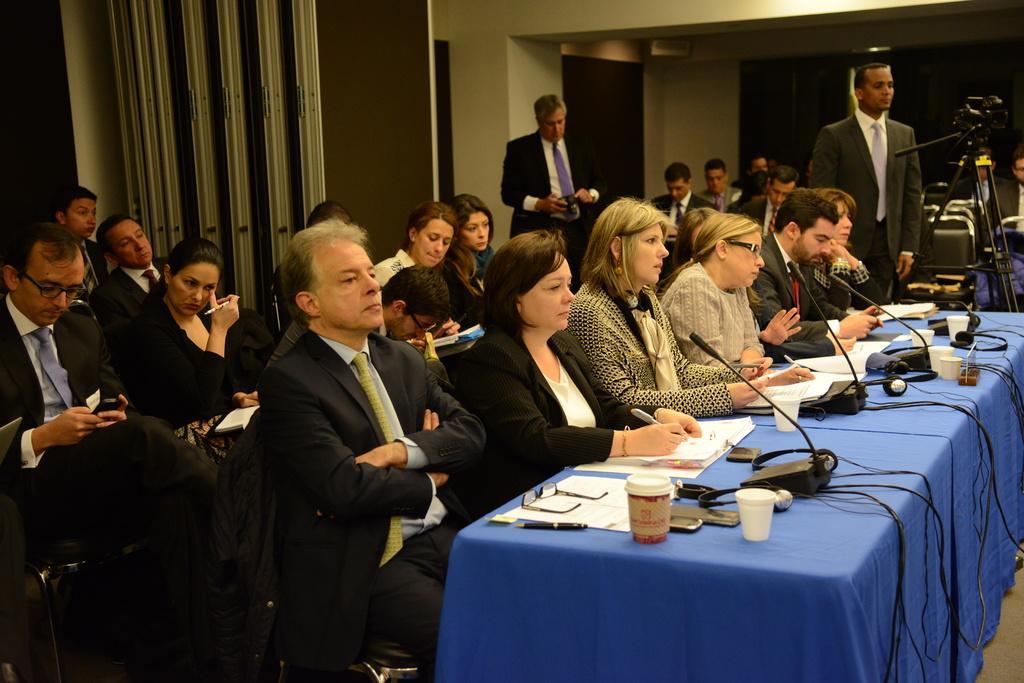Could you give a brief overview of what you see in this image? In this image I can see few people with different color dresses. I can see few people are sitting and two people are standing. I can see the table in-front of few people. On the table I can see the mics, papers, cups, specs, pens and also wires. And there is a cream and brown color background. 